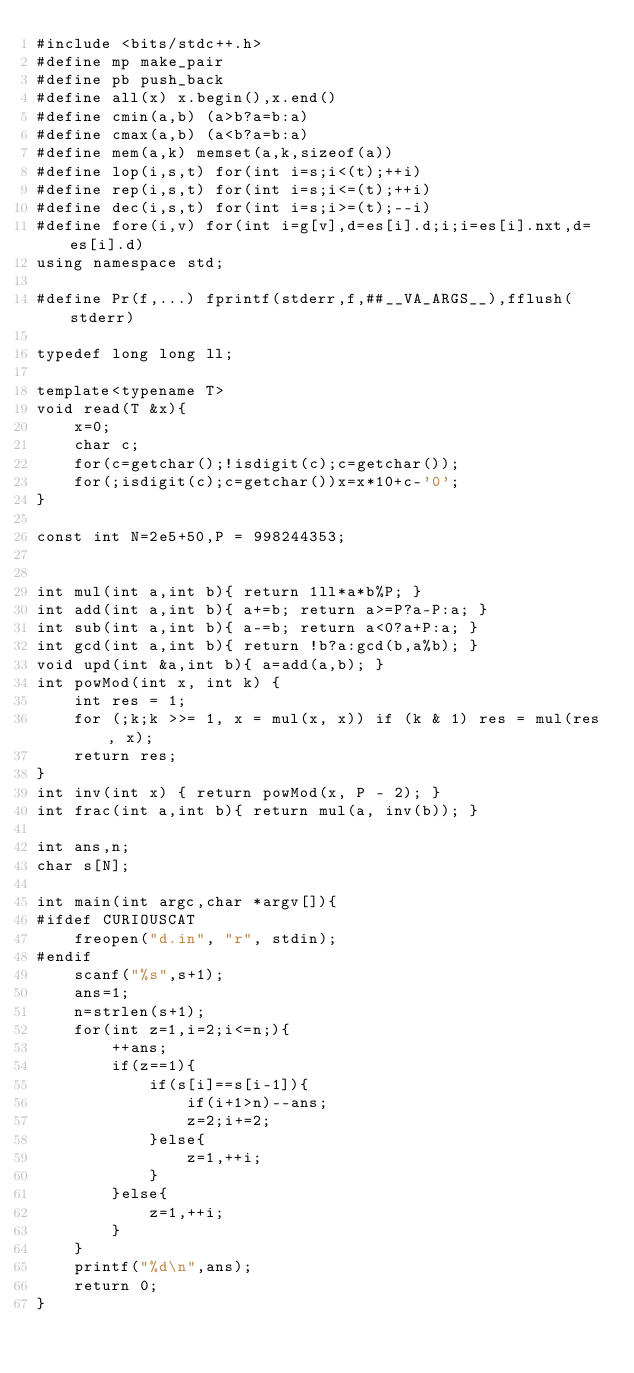Convert code to text. <code><loc_0><loc_0><loc_500><loc_500><_C++_>#include <bits/stdc++.h>
#define mp make_pair
#define pb push_back
#define all(x) x.begin(),x.end()
#define cmin(a,b) (a>b?a=b:a)
#define cmax(a,b) (a<b?a=b:a)
#define mem(a,k) memset(a,k,sizeof(a))
#define lop(i,s,t) for(int i=s;i<(t);++i)
#define rep(i,s,t) for(int i=s;i<=(t);++i)
#define dec(i,s,t) for(int i=s;i>=(t);--i)
#define fore(i,v) for(int i=g[v],d=es[i].d;i;i=es[i].nxt,d=es[i].d)
using namespace std;

#define Pr(f,...) fprintf(stderr,f,##__VA_ARGS__),fflush(stderr)

typedef long long ll;

template<typename T>
void read(T &x){
	x=0; 
	char c;
	for(c=getchar();!isdigit(c);c=getchar()); 
	for(;isdigit(c);c=getchar())x=x*10+c-'0'; 
}

const int N=2e5+50,P = 998244353;


int mul(int a,int b){ return 1ll*a*b%P; }
int add(int a,int b){ a+=b; return a>=P?a-P:a; }
int sub(int a,int b){ a-=b; return a<0?a+P:a; }
int gcd(int a,int b){ return !b?a:gcd(b,a%b); }
void upd(int &a,int b){ a=add(a,b); }
int powMod(int x, int k) {
	int res = 1;
	for (;k;k >>= 1, x = mul(x, x)) if (k & 1) res = mul(res, x); 
	return res;
}
int inv(int x) { return powMod(x, P - 2); } 
int frac(int a,int b){ return mul(a, inv(b)); }

int ans,n;
char s[N]; 

int main(int argc,char *argv[]){
#ifdef CURIOUSCAT
	freopen("d.in", "r", stdin); 
#endif
	scanf("%s",s+1);
	ans=1;
	n=strlen(s+1);
	for(int z=1,i=2;i<=n;){
		++ans;
		if(z==1){
			if(s[i]==s[i-1]){
				if(i+1>n)--ans;
				z=2;i+=2;
			}else{
				z=1,++i;
			}
		}else{
			z=1,++i;
		}
	}
	printf("%d\n",ans);
	return 0;
}</code> 